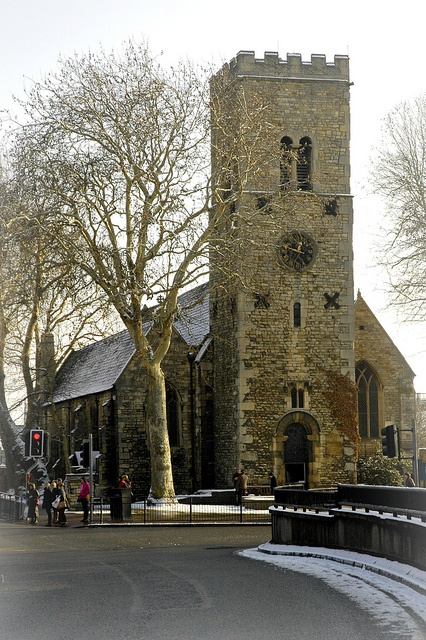Describe the objects in this image and their specific colors. I can see clock in white, black, darkgreen, and gray tones, traffic light in white, black, and gray tones, people in white, black, gray, and tan tones, people in white, black, gray, maroon, and darkgray tones, and people in white, black, maroon, and purple tones in this image. 